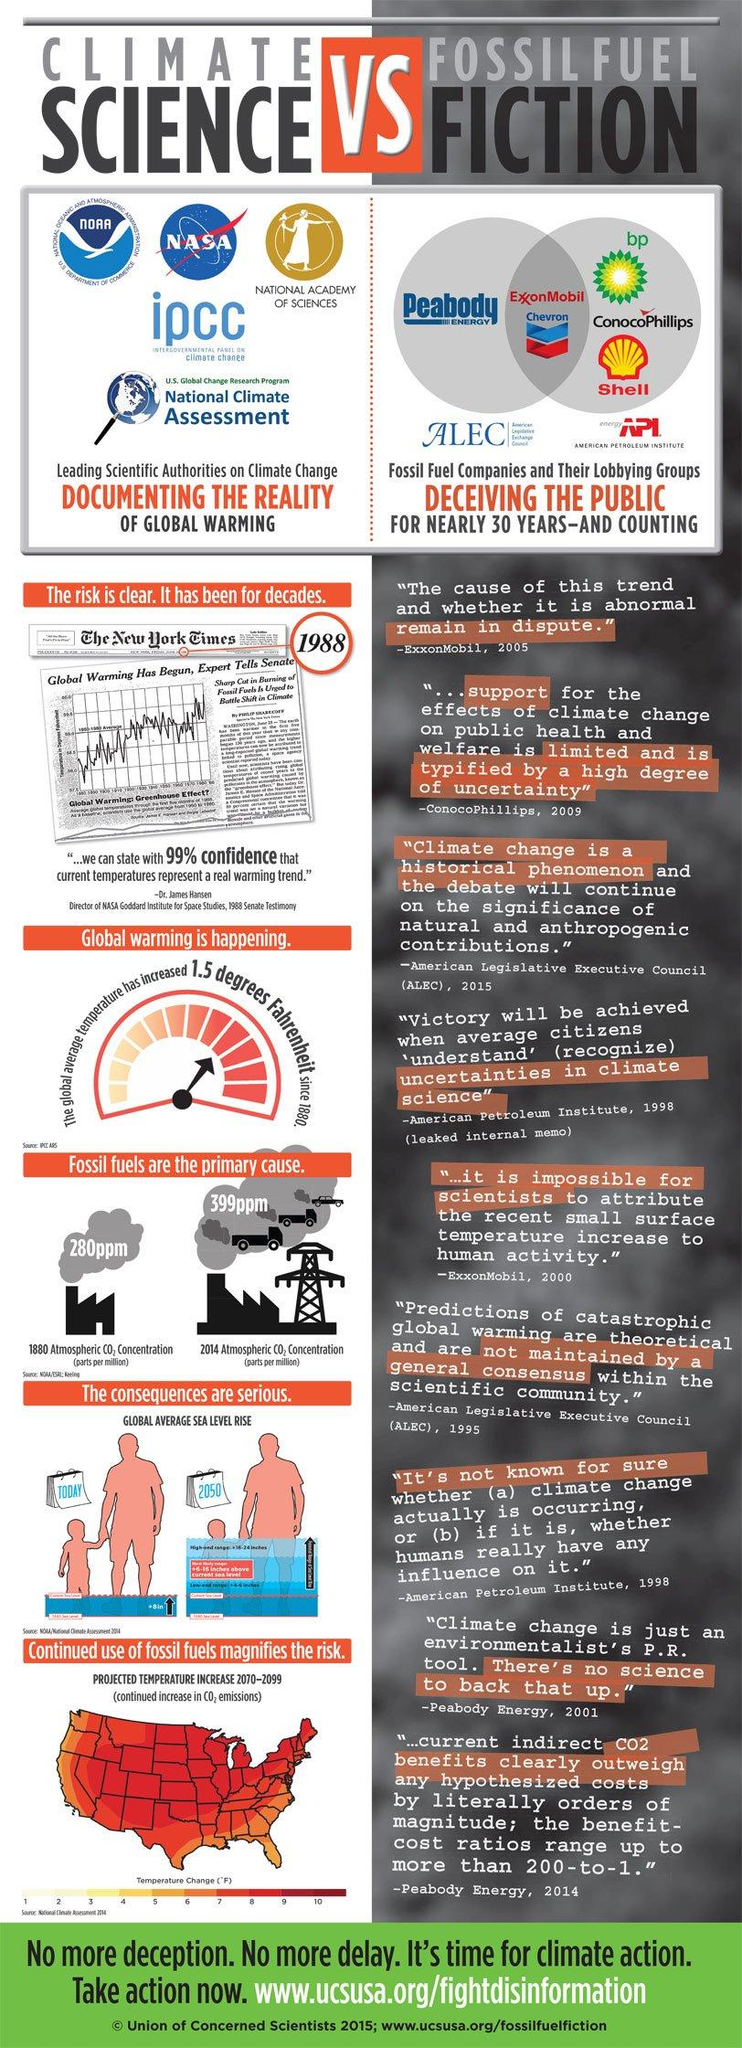Mention a couple of crucial points in this snapshot. It is a fact that fossil fuel companies and their lobbying groups are knowingly misleading the public about the issue of global warming. In 1880, the atmospheric carbon dioxide concentration was 280 parts per million. In 2014, the atmospheric concentration of carbon dioxide was approximately 399 parts per million. In 1988, Dr. James Hansen testified before the Senate about the issue of global warming. The image represents a significant increase in global sea level by the year 2050. 